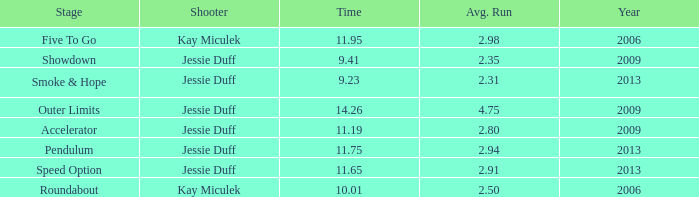What is the cumulative years with mean scores below 0.0. 